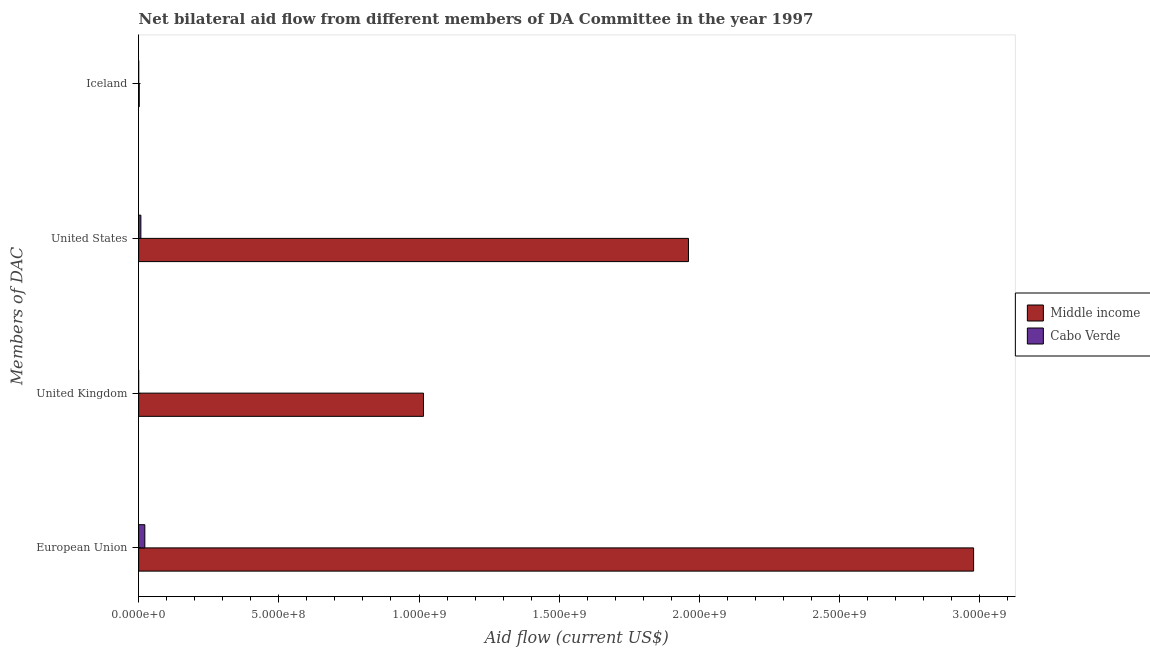How many different coloured bars are there?
Your answer should be very brief. 2. What is the amount of aid given by uk in Cabo Verde?
Offer a very short reply. 4.00e+04. Across all countries, what is the maximum amount of aid given by iceland?
Keep it short and to the point. 2.18e+06. Across all countries, what is the minimum amount of aid given by iceland?
Offer a very short reply. 2.20e+05. In which country was the amount of aid given by uk minimum?
Make the answer very short. Cabo Verde. What is the total amount of aid given by eu in the graph?
Offer a very short reply. 3.00e+09. What is the difference between the amount of aid given by us in Middle income and that in Cabo Verde?
Your answer should be very brief. 1.95e+09. What is the difference between the amount of aid given by uk in Middle income and the amount of aid given by us in Cabo Verde?
Offer a terse response. 1.01e+09. What is the average amount of aid given by eu per country?
Your answer should be compact. 1.50e+09. What is the difference between the amount of aid given by us and amount of aid given by eu in Cabo Verde?
Your answer should be compact. -1.41e+07. In how many countries, is the amount of aid given by uk greater than 2300000000 US$?
Provide a short and direct response. 0. What is the ratio of the amount of aid given by uk in Cabo Verde to that in Middle income?
Make the answer very short. 3.937317899047169e-5. Is the difference between the amount of aid given by us in Cabo Verde and Middle income greater than the difference between the amount of aid given by uk in Cabo Verde and Middle income?
Your response must be concise. No. What is the difference between the highest and the second highest amount of aid given by uk?
Make the answer very short. 1.02e+09. What is the difference between the highest and the lowest amount of aid given by iceland?
Ensure brevity in your answer.  1.96e+06. In how many countries, is the amount of aid given by eu greater than the average amount of aid given by eu taken over all countries?
Make the answer very short. 1. Is the sum of the amount of aid given by eu in Middle income and Cabo Verde greater than the maximum amount of aid given by iceland across all countries?
Your answer should be very brief. Yes. Is it the case that in every country, the sum of the amount of aid given by us and amount of aid given by eu is greater than the sum of amount of aid given by iceland and amount of aid given by uk?
Keep it short and to the point. No. What does the 1st bar from the bottom in United Kingdom represents?
Your response must be concise. Middle income. Is it the case that in every country, the sum of the amount of aid given by eu and amount of aid given by uk is greater than the amount of aid given by us?
Ensure brevity in your answer.  Yes. How many bars are there?
Your answer should be very brief. 8. Are all the bars in the graph horizontal?
Your answer should be very brief. Yes. Where does the legend appear in the graph?
Give a very brief answer. Center right. How are the legend labels stacked?
Your answer should be compact. Vertical. What is the title of the graph?
Your response must be concise. Net bilateral aid flow from different members of DA Committee in the year 1997. What is the label or title of the Y-axis?
Provide a succinct answer. Members of DAC. What is the Aid flow (current US$) of Middle income in European Union?
Make the answer very short. 2.98e+09. What is the Aid flow (current US$) in Cabo Verde in European Union?
Your answer should be very brief. 2.21e+07. What is the Aid flow (current US$) in Middle income in United Kingdom?
Provide a succinct answer. 1.02e+09. What is the Aid flow (current US$) of Cabo Verde in United Kingdom?
Keep it short and to the point. 4.00e+04. What is the Aid flow (current US$) in Middle income in United States?
Your answer should be very brief. 1.96e+09. What is the Aid flow (current US$) of Cabo Verde in United States?
Ensure brevity in your answer.  8.00e+06. What is the Aid flow (current US$) of Middle income in Iceland?
Give a very brief answer. 2.18e+06. Across all Members of DAC, what is the maximum Aid flow (current US$) in Middle income?
Make the answer very short. 2.98e+09. Across all Members of DAC, what is the maximum Aid flow (current US$) of Cabo Verde?
Your answer should be compact. 2.21e+07. Across all Members of DAC, what is the minimum Aid flow (current US$) in Middle income?
Make the answer very short. 2.18e+06. What is the total Aid flow (current US$) of Middle income in the graph?
Provide a succinct answer. 5.96e+09. What is the total Aid flow (current US$) of Cabo Verde in the graph?
Your answer should be compact. 3.04e+07. What is the difference between the Aid flow (current US$) in Middle income in European Union and that in United Kingdom?
Offer a very short reply. 1.96e+09. What is the difference between the Aid flow (current US$) of Cabo Verde in European Union and that in United Kingdom?
Your answer should be very brief. 2.20e+07. What is the difference between the Aid flow (current US$) in Middle income in European Union and that in United States?
Provide a short and direct response. 1.02e+09. What is the difference between the Aid flow (current US$) of Cabo Verde in European Union and that in United States?
Your answer should be very brief. 1.41e+07. What is the difference between the Aid flow (current US$) of Middle income in European Union and that in Iceland?
Ensure brevity in your answer.  2.98e+09. What is the difference between the Aid flow (current US$) in Cabo Verde in European Union and that in Iceland?
Your response must be concise. 2.19e+07. What is the difference between the Aid flow (current US$) of Middle income in United Kingdom and that in United States?
Your answer should be very brief. -9.45e+08. What is the difference between the Aid flow (current US$) of Cabo Verde in United Kingdom and that in United States?
Make the answer very short. -7.96e+06. What is the difference between the Aid flow (current US$) in Middle income in United Kingdom and that in Iceland?
Keep it short and to the point. 1.01e+09. What is the difference between the Aid flow (current US$) in Cabo Verde in United Kingdom and that in Iceland?
Provide a succinct answer. -1.80e+05. What is the difference between the Aid flow (current US$) in Middle income in United States and that in Iceland?
Offer a very short reply. 1.96e+09. What is the difference between the Aid flow (current US$) in Cabo Verde in United States and that in Iceland?
Make the answer very short. 7.78e+06. What is the difference between the Aid flow (current US$) of Middle income in European Union and the Aid flow (current US$) of Cabo Verde in United Kingdom?
Offer a terse response. 2.98e+09. What is the difference between the Aid flow (current US$) of Middle income in European Union and the Aid flow (current US$) of Cabo Verde in United States?
Keep it short and to the point. 2.97e+09. What is the difference between the Aid flow (current US$) in Middle income in European Union and the Aid flow (current US$) in Cabo Verde in Iceland?
Offer a terse response. 2.98e+09. What is the difference between the Aid flow (current US$) of Middle income in United Kingdom and the Aid flow (current US$) of Cabo Verde in United States?
Your answer should be very brief. 1.01e+09. What is the difference between the Aid flow (current US$) in Middle income in United Kingdom and the Aid flow (current US$) in Cabo Verde in Iceland?
Provide a succinct answer. 1.02e+09. What is the difference between the Aid flow (current US$) in Middle income in United States and the Aid flow (current US$) in Cabo Verde in Iceland?
Provide a succinct answer. 1.96e+09. What is the average Aid flow (current US$) of Middle income per Members of DAC?
Your answer should be very brief. 1.49e+09. What is the average Aid flow (current US$) in Cabo Verde per Members of DAC?
Keep it short and to the point. 7.59e+06. What is the difference between the Aid flow (current US$) of Middle income and Aid flow (current US$) of Cabo Verde in European Union?
Your answer should be compact. 2.96e+09. What is the difference between the Aid flow (current US$) of Middle income and Aid flow (current US$) of Cabo Verde in United Kingdom?
Provide a short and direct response. 1.02e+09. What is the difference between the Aid flow (current US$) of Middle income and Aid flow (current US$) of Cabo Verde in United States?
Your answer should be compact. 1.95e+09. What is the difference between the Aid flow (current US$) of Middle income and Aid flow (current US$) of Cabo Verde in Iceland?
Your response must be concise. 1.96e+06. What is the ratio of the Aid flow (current US$) in Middle income in European Union to that in United Kingdom?
Your answer should be very brief. 2.93. What is the ratio of the Aid flow (current US$) of Cabo Verde in European Union to that in United Kingdom?
Provide a short and direct response. 552.25. What is the ratio of the Aid flow (current US$) of Middle income in European Union to that in United States?
Provide a succinct answer. 1.52. What is the ratio of the Aid flow (current US$) of Cabo Verde in European Union to that in United States?
Make the answer very short. 2.76. What is the ratio of the Aid flow (current US$) of Middle income in European Union to that in Iceland?
Offer a terse response. 1366.02. What is the ratio of the Aid flow (current US$) in Cabo Verde in European Union to that in Iceland?
Provide a succinct answer. 100.41. What is the ratio of the Aid flow (current US$) in Middle income in United Kingdom to that in United States?
Make the answer very short. 0.52. What is the ratio of the Aid flow (current US$) in Cabo Verde in United Kingdom to that in United States?
Provide a succinct answer. 0.01. What is the ratio of the Aid flow (current US$) in Middle income in United Kingdom to that in Iceland?
Keep it short and to the point. 466.02. What is the ratio of the Aid flow (current US$) of Cabo Verde in United Kingdom to that in Iceland?
Your response must be concise. 0.18. What is the ratio of the Aid flow (current US$) in Middle income in United States to that in Iceland?
Offer a terse response. 899.54. What is the ratio of the Aid flow (current US$) of Cabo Verde in United States to that in Iceland?
Your response must be concise. 36.36. What is the difference between the highest and the second highest Aid flow (current US$) of Middle income?
Provide a short and direct response. 1.02e+09. What is the difference between the highest and the second highest Aid flow (current US$) of Cabo Verde?
Your answer should be compact. 1.41e+07. What is the difference between the highest and the lowest Aid flow (current US$) in Middle income?
Make the answer very short. 2.98e+09. What is the difference between the highest and the lowest Aid flow (current US$) in Cabo Verde?
Provide a short and direct response. 2.20e+07. 